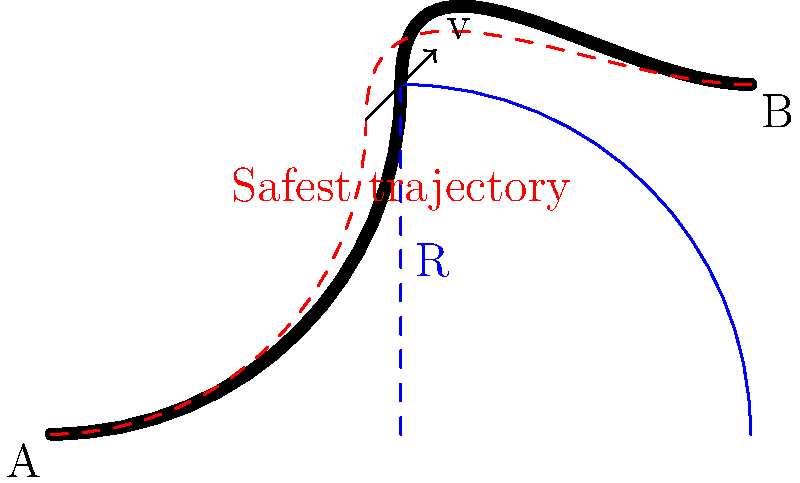A skilled driver approaches a curved road segment as shown in the diagram. The curve has a constant radius of curvature R. Given that the vehicle's speed is v, and the coefficient of friction between the tires and the road is μ, determine the maximum safe speed v_max for negotiating the curve without skidding. Express your answer in terms of R, g (acceleration due to gravity), and μ. To determine the maximum safe speed for negotiating the curve, we need to consider the balance of forces acting on the vehicle:

1. The centripetal force required to keep the vehicle on the curved path is given by:
   $$F_c = \frac{mv^2}{R}$$
   where m is the mass of the vehicle, v is the velocity, and R is the radius of curvature.

2. The maximum friction force available between the tires and the road is:
   $$F_f = μmg$$
   where μ is the coefficient of friction and g is the acceleration due to gravity.

3. For the vehicle to negotiate the curve safely, the centripetal force must not exceed the maximum friction force:
   $$\frac{mv^2}{R} \leq μmg$$

4. Solving for v:
   $$v^2 \leq μgR$$
   $$v \leq \sqrt{μgR}$$

5. Therefore, the maximum safe speed v_max is:
   $$v_{max} = \sqrt{μgR}$$

This equation shows that the maximum safe speed increases with the square root of the radius of curvature and the coefficient of friction, which aligns with practical driving experience. A larger radius allows for higher speeds, as does better tire grip on the road surface.
Answer: $$v_{max} = \sqrt{μgR}$$ 